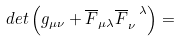Convert formula to latex. <formula><loc_0><loc_0><loc_500><loc_500>d e t \left ( g _ { \mu \nu } + \overline { F } _ { \mu \lambda } \overline { F } _ { \nu } ^ { \ \lambda } \right ) = \text { \quad }</formula> 